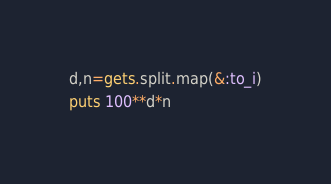Convert code to text. <code><loc_0><loc_0><loc_500><loc_500><_Ruby_>d,n=gets.split.map(&:to_i)
puts 100**d*n</code> 